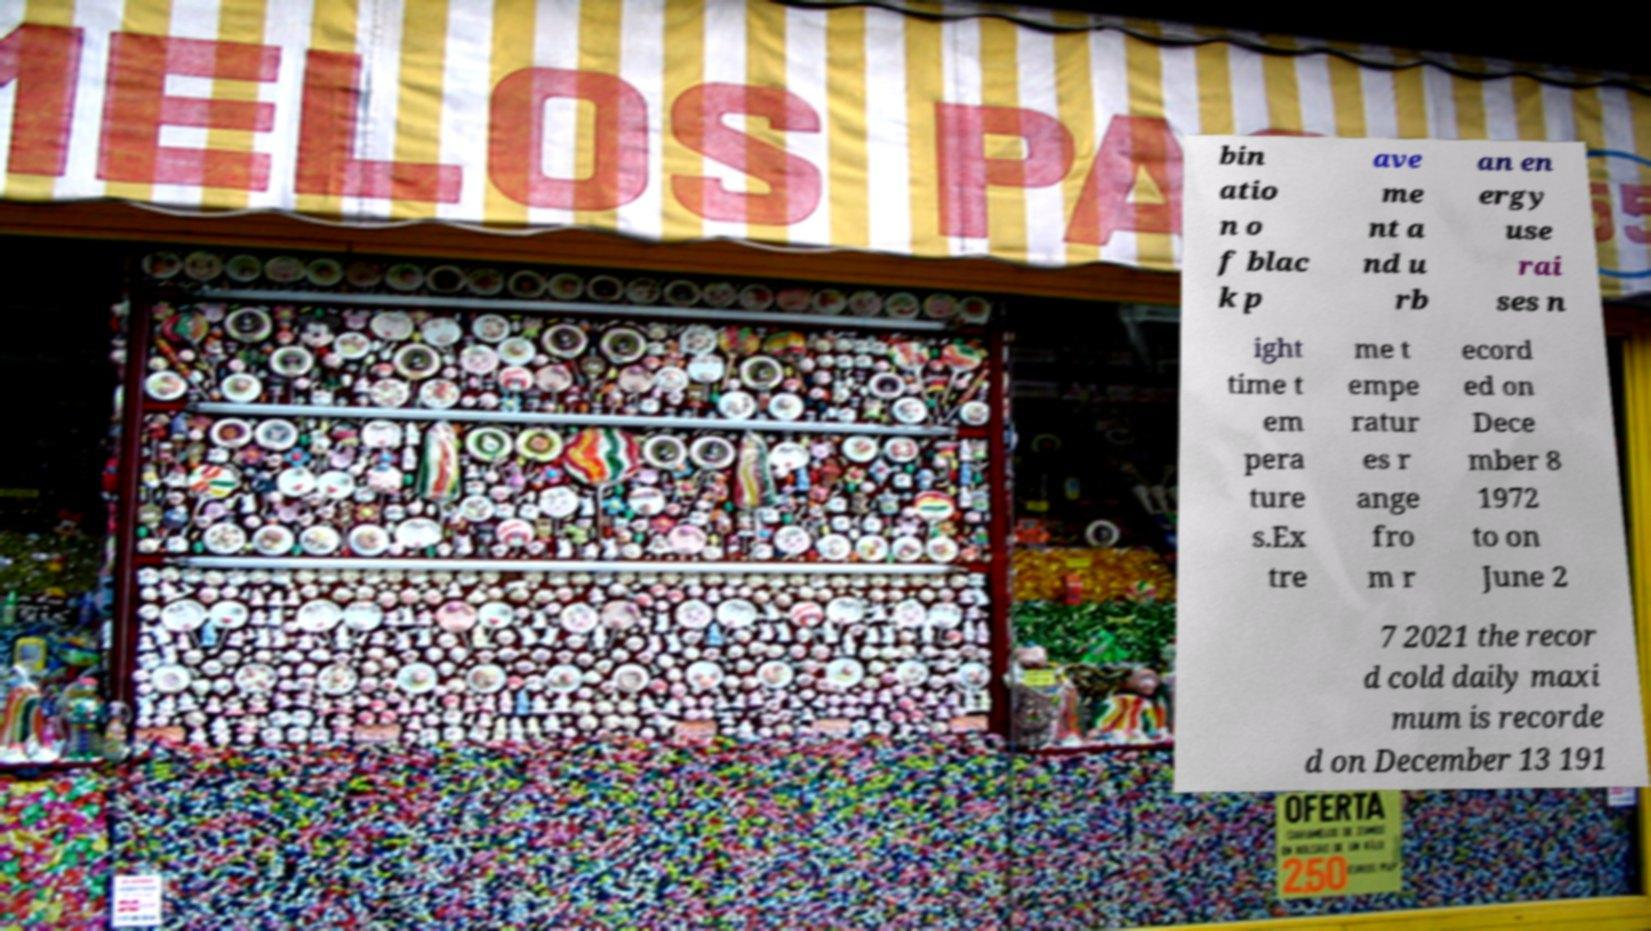For documentation purposes, I need the text within this image transcribed. Could you provide that? bin atio n o f blac k p ave me nt a nd u rb an en ergy use rai ses n ight time t em pera ture s.Ex tre me t empe ratur es r ange fro m r ecord ed on Dece mber 8 1972 to on June 2 7 2021 the recor d cold daily maxi mum is recorde d on December 13 191 